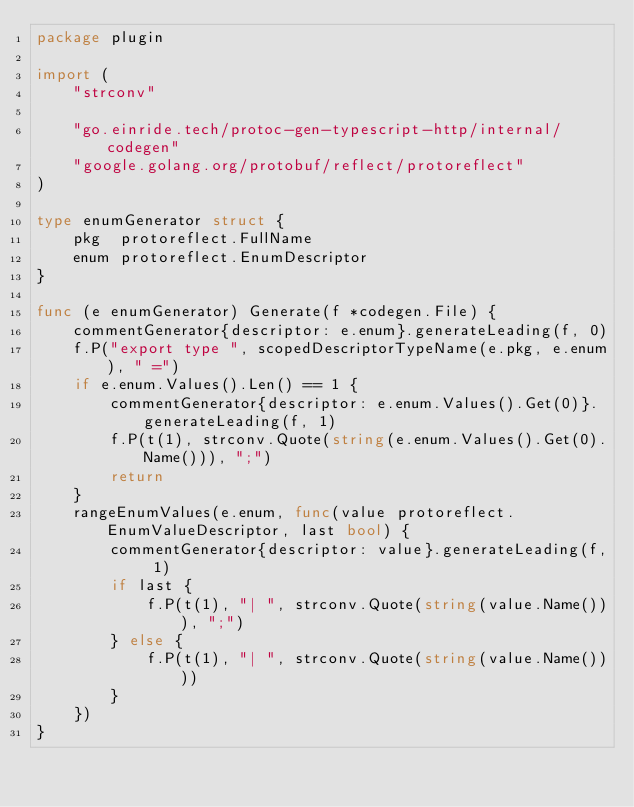Convert code to text. <code><loc_0><loc_0><loc_500><loc_500><_Go_>package plugin

import (
	"strconv"

	"go.einride.tech/protoc-gen-typescript-http/internal/codegen"
	"google.golang.org/protobuf/reflect/protoreflect"
)

type enumGenerator struct {
	pkg  protoreflect.FullName
	enum protoreflect.EnumDescriptor
}

func (e enumGenerator) Generate(f *codegen.File) {
	commentGenerator{descriptor: e.enum}.generateLeading(f, 0)
	f.P("export type ", scopedDescriptorTypeName(e.pkg, e.enum), " =")
	if e.enum.Values().Len() == 1 {
		commentGenerator{descriptor: e.enum.Values().Get(0)}.generateLeading(f, 1)
		f.P(t(1), strconv.Quote(string(e.enum.Values().Get(0).Name())), ";")
		return
	}
	rangeEnumValues(e.enum, func(value protoreflect.EnumValueDescriptor, last bool) {
		commentGenerator{descriptor: value}.generateLeading(f, 1)
		if last {
			f.P(t(1), "| ", strconv.Quote(string(value.Name())), ";")
		} else {
			f.P(t(1), "| ", strconv.Quote(string(value.Name())))
		}
	})
}
</code> 